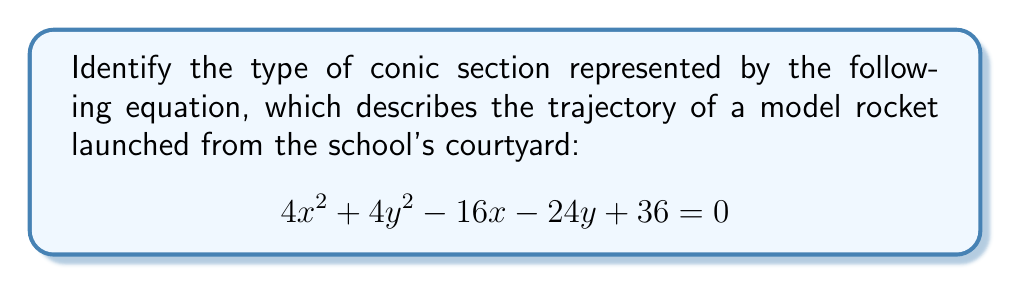Show me your answer to this math problem. To identify the type of conic section, we need to analyze the coefficients of the general equation:

$$Ax^2 + Bxy + Cy^2 + Dx + Ey + F = 0$$

1. First, we rearrange the given equation to match this form:
   $$4x^2 + 4y^2 - 16x - 24y + 36 = 0$$

2. We can identify the coefficients:
   $A = 4$, $B = 0$, $C = 4$, $D = -16$, $E = -24$, $F = 36$

3. To determine the type of conic section, we calculate the discriminant:
   $$\Delta = B^2 - 4AC$$
   $$\Delta = 0^2 - 4(4)(4) = 0 - 64 = -64$$

4. Since $\Delta < 0$ and $A = C$, we can conclude that this equation represents a circle.

5. To verify, we can complete the square for both $x$ and $y$ terms:
   $$4(x^2 - 4x) + 4(y^2 - 6y) + 36 = 0$$
   $$4(x^2 - 4x + 4) + 4(y^2 - 6y + 9) + 36 - 16 - 36 = 0$$
   $$4(x - 2)^2 + 4(y - 3)^2 = 16$$
   $$(x - 2)^2 + (y - 3)^2 = 4$$

This is indeed the standard form of a circle with center (2, 3) and radius 2.
Answer: Circle 